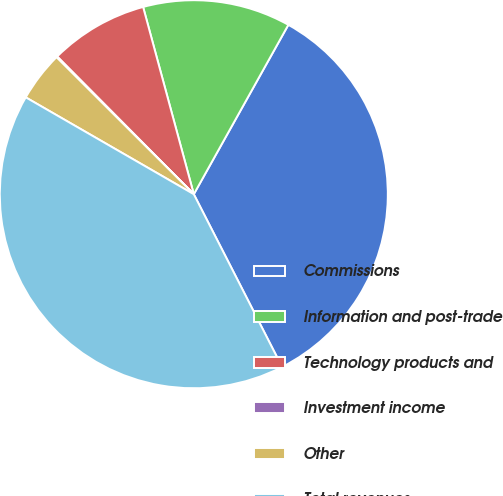<chart> <loc_0><loc_0><loc_500><loc_500><pie_chart><fcel>Commissions<fcel>Information and post-trade<fcel>Technology products and<fcel>Investment income<fcel>Other<fcel>Total revenues<nl><fcel>34.38%<fcel>12.31%<fcel>8.23%<fcel>0.08%<fcel>4.16%<fcel>40.84%<nl></chart> 